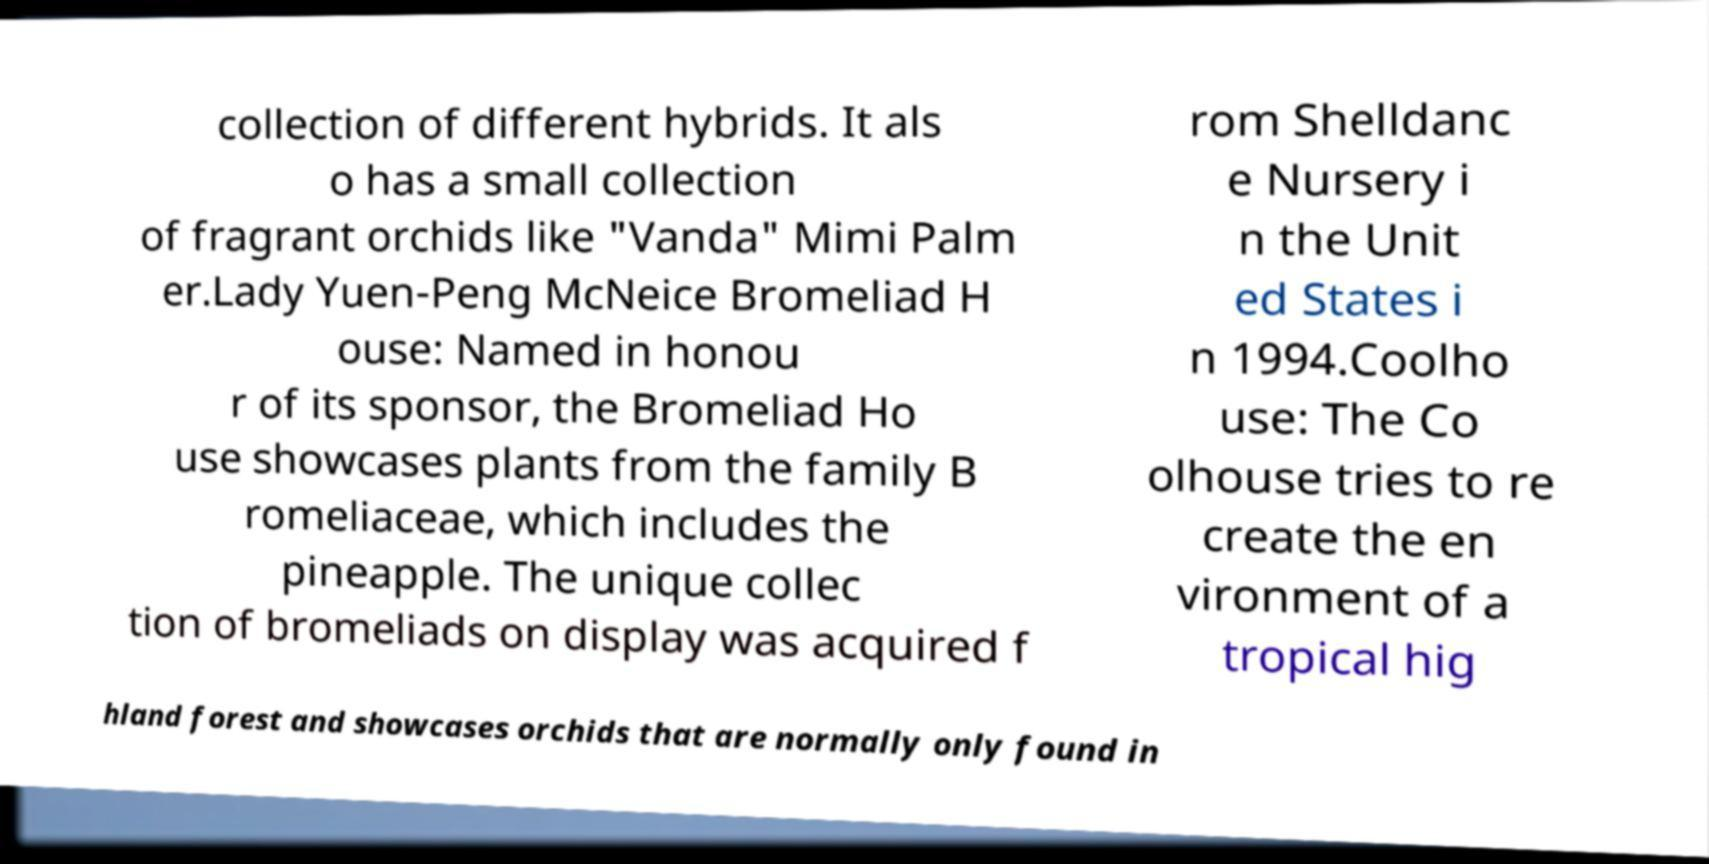Please identify and transcribe the text found in this image. collection of different hybrids. It als o has a small collection of fragrant orchids like "Vanda" Mimi Palm er.Lady Yuen-Peng McNeice Bromeliad H ouse: Named in honou r of its sponsor, the Bromeliad Ho use showcases plants from the family B romeliaceae, which includes the pineapple. The unique collec tion of bromeliads on display was acquired f rom Shelldanc e Nursery i n the Unit ed States i n 1994.Coolho use: The Co olhouse tries to re create the en vironment of a tropical hig hland forest and showcases orchids that are normally only found in 